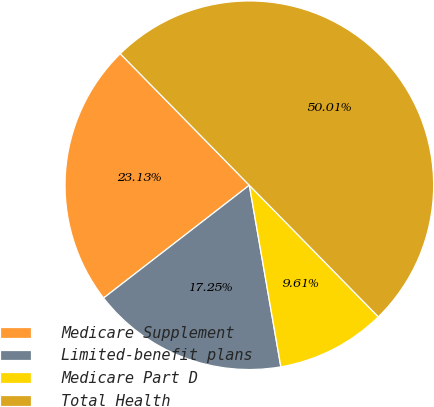<chart> <loc_0><loc_0><loc_500><loc_500><pie_chart><fcel>Medicare Supplement<fcel>Limited-benefit plans<fcel>Medicare Part D<fcel>Total Health<nl><fcel>23.13%<fcel>17.25%<fcel>9.61%<fcel>50.0%<nl></chart> 